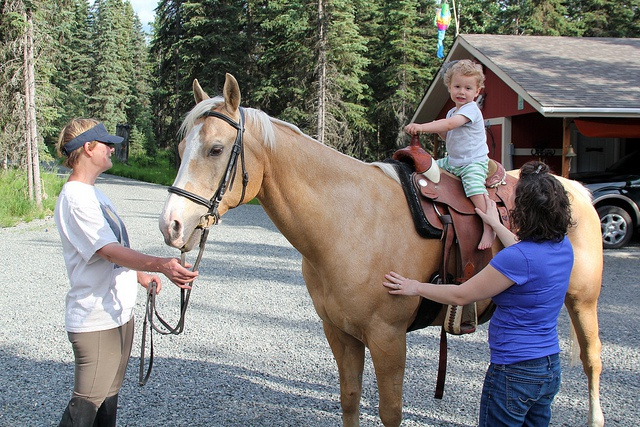Describe the objects in this image and their specific colors. I can see horse in beige, darkgray, tan, maroon, and gray tones, people in beige, white, darkgray, and gray tones, people in beige, black, navy, and blue tones, people in beige, darkgray, lavender, gray, and black tones, and truck in beige, black, gray, and darkgray tones in this image. 